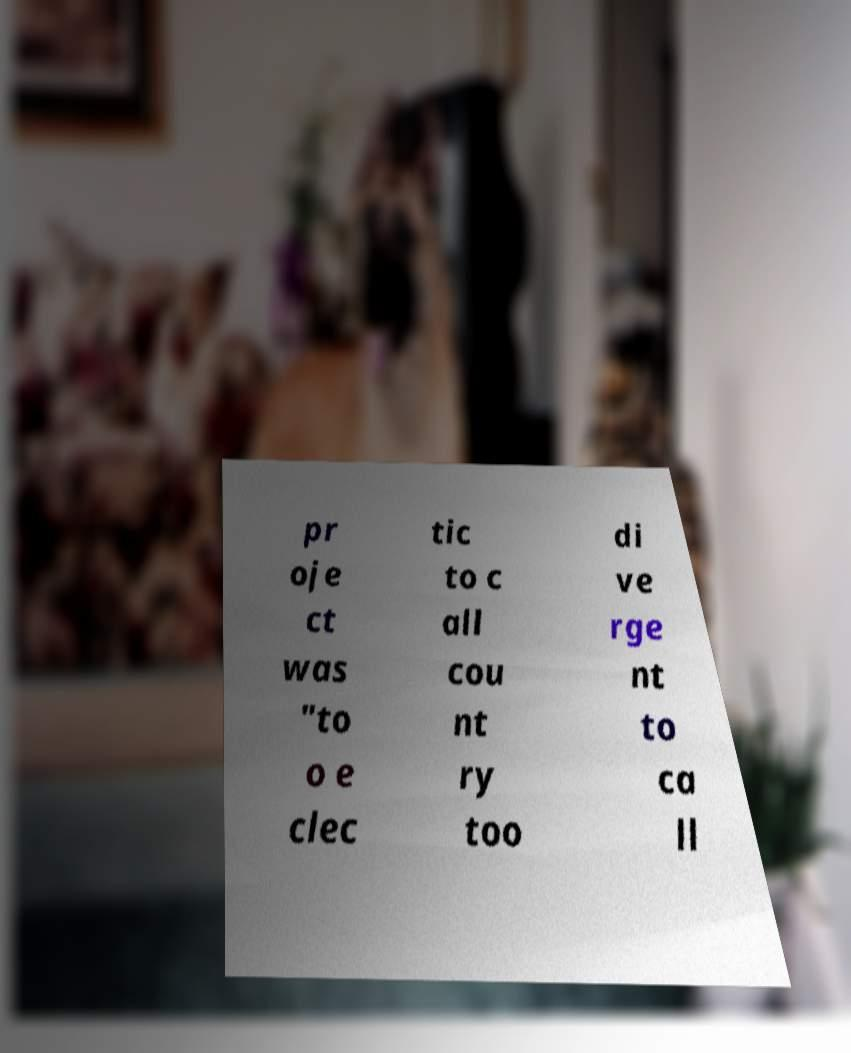Could you extract and type out the text from this image? pr oje ct was "to o e clec tic to c all cou nt ry too di ve rge nt to ca ll 